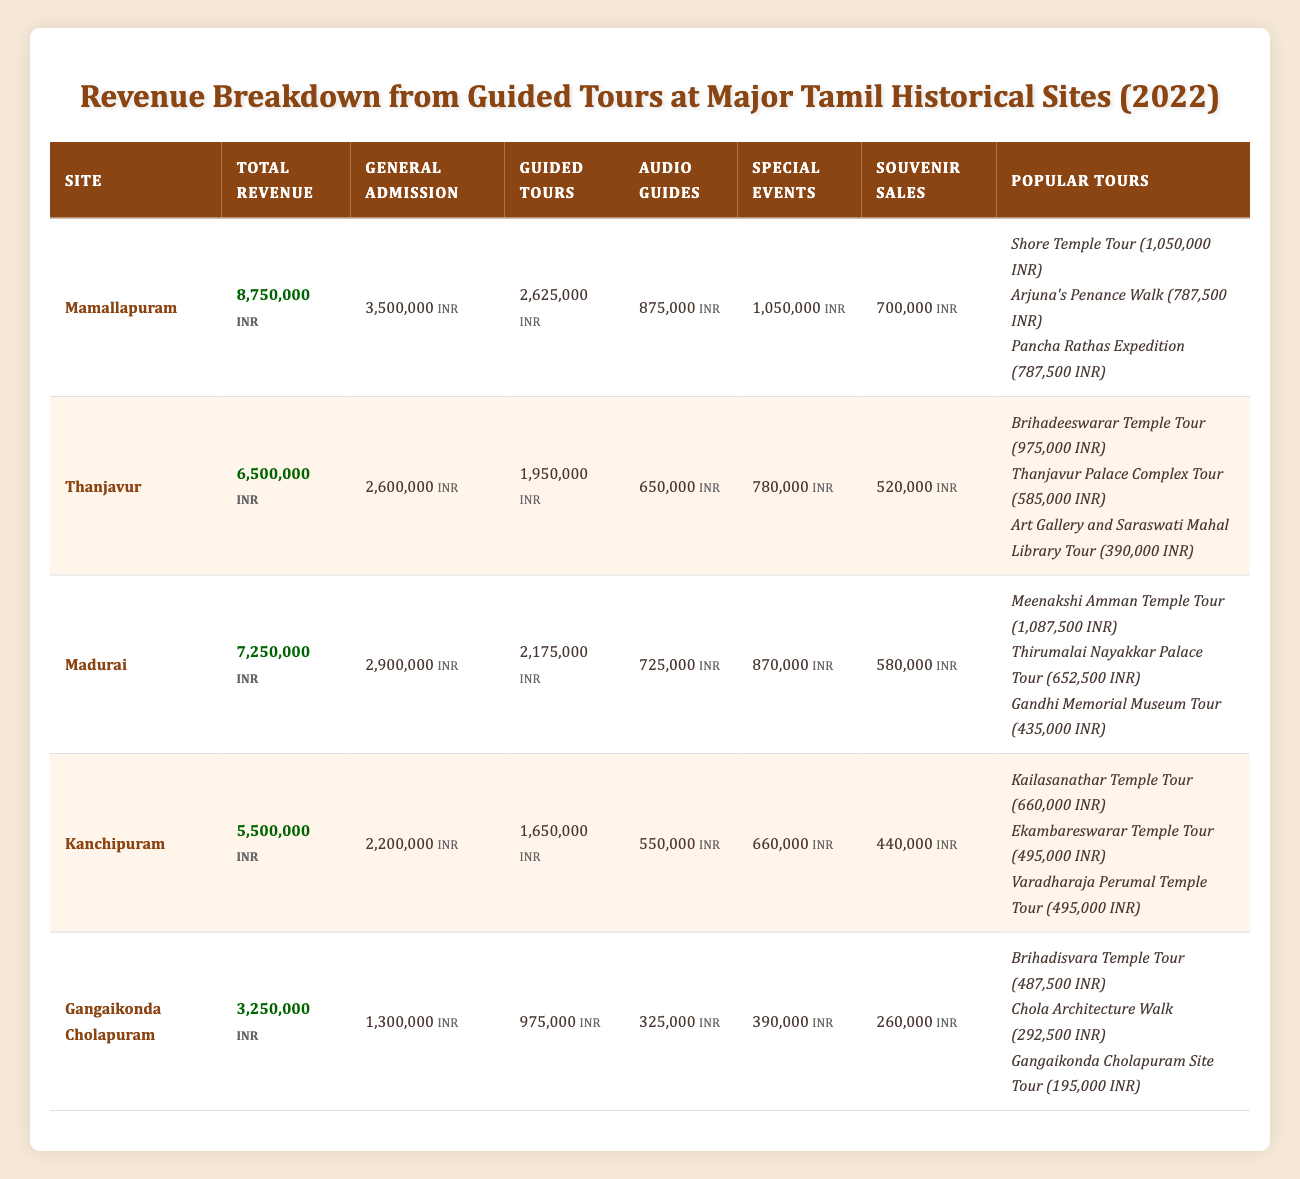What is the total revenue generated from guided tours at Mamallapuram? The total revenue from guided tours at Mamallapuram is found directly from the revenue breakdown row in the table, which shows a value of 2,625,000 INR for guided tours.
Answer: 2,625,000 INR Which site had the highest total revenue in 2022? By comparing the total revenue figures from each site, Mamallapuram has the highest total revenue at 8,750,000 INR, which is greater than the other listed sites.
Answer: Mamallapuram What is the difference in guided tour revenue between Madurai and Kanchipuram? The guided tour revenue for Madurai is 2,175,000 INR and for Kanchipuram, it is 1,650,000 INR. The difference is calculated as follows: 2,175,000 - 1,650,000 = 525,000 INR.
Answer: 525,000 INR Is the revenue from guided tours at Thanjavur greater than the combined revenue from audio guides and souvenir sales? The revenue from guided tours at Thanjavur is 1,950,000 INR. The combined revenue from audio guides (650,000 INR) and souvenir sales (520,000 INR) totals 1,170,000 INR. Since 1,950,000 is greater than 1,170,000, the statement is true.
Answer: Yes What is the average revenue from the top three popular tours at Madurai? The revenues from the top three popular tours at Madurai are as follows: Meenakshi Amman Temple Tour (1,087,500 INR), Thirumalai Nayakkar Palace Tour (652,500 INR), and Gandhi Memorial Museum Tour (435,000 INR). Summing these gives 1,087,500 + 652,500 + 435,000 = 2,175,000 INR. To find the average, divide by the number of tours: 2,175,000 / 3 = 725,000 INR.
Answer: 725,000 INR Which site generated the least revenue from general admission? The general admission revenue for each site is: Mamallapuram (3,500,000 INR), Thanjavur (2,600,000 INR), Madurai (2,900,000 INR), Kanchipuram (2,200,000 INR), and Gangaikonda Cholapuram (1,300,000 INR). Gangaikonda Cholapuram has the lowest figure, which is 1,300,000 INR.
Answer: Gangaikonda Cholapuram How much revenue was generated from special events across all sites combined? To find the total revenue from special events, add the special event revenues for all sites: Mamallapuram (1,050,000 INR) + Thanjavur (780,000 INR) + Madurai (870,000 INR) + Kanchipuram (660,000 INR) + Gangaikonda Cholapuram (390,000 INR) = 3,750,000 INR.
Answer: 3,750,000 INR Did the revenue from audio guides in Mamallapuram exceed the total revenue from guided tours at Gangaikonda Cholapuram? The revenue from audio guides in Mamallapuram is 875,000 INR, while the guided tour revenue in Gangaikonda Cholapuram is 975,000 INR. Since 875,000 is less than 975,000, the answer is false.
Answer: No What percentage of the total revenue at Kanchipuram came from guided tours? The total revenue at Kanchipuram is 5,500,000 INR, and the guided tour revenue is 1,650,000 INR. To find the percentage, use the formula: (1,650,000 / 5,500,000) * 100 = 30%.
Answer: 30% 